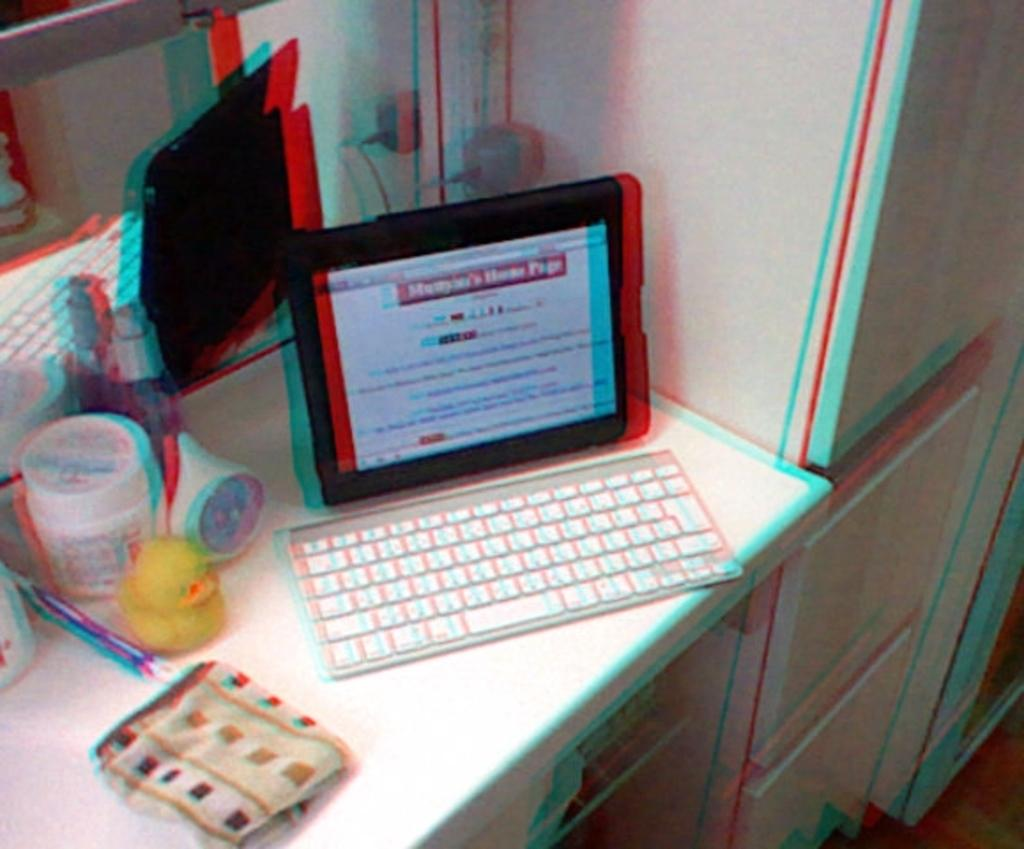What electronic device is visible in the image? There is a tablet PC in the image. What feature does the tablet PC have? The tablet PC has a keyboard. What else can be seen on the table besides the tablet PC? There are other articles on the table. Where are the tablet PC and other articles located? The tablet PC and other articles are placed on a table. How does the baby interact with the memory on the tablet PC in the image? There is no baby present in the image, so it is not possible to determine how a baby might interact with the tablet PC or its memory. 